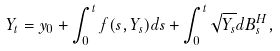Convert formula to latex. <formula><loc_0><loc_0><loc_500><loc_500>Y _ { t } = y _ { 0 } + \int _ { 0 } ^ { t } f ( s , Y _ { s } ) d s + \int _ { 0 } ^ { t } \sqrt { Y _ { s } } d B _ { s } ^ { H } ,</formula> 